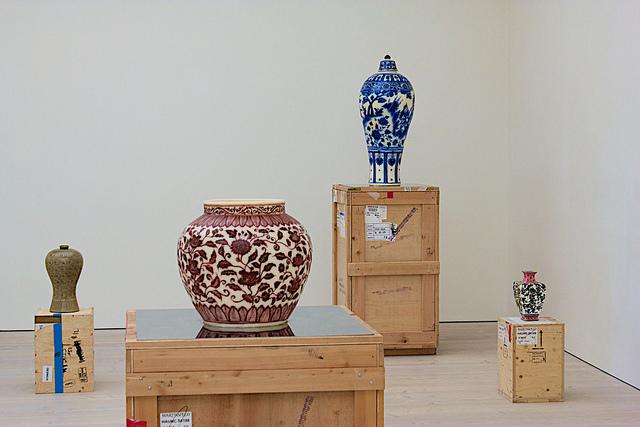Are all the vases the same size?
Short answer required. No. What type of vases are these?
Keep it brief. Chinese. Is this an art exhibit?
Short answer required. Yes. 